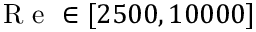<formula> <loc_0><loc_0><loc_500><loc_500>R e \in [ 2 5 0 0 , 1 0 0 0 0 ]</formula> 